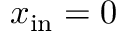Convert formula to latex. <formula><loc_0><loc_0><loc_500><loc_500>x _ { i n } = 0</formula> 